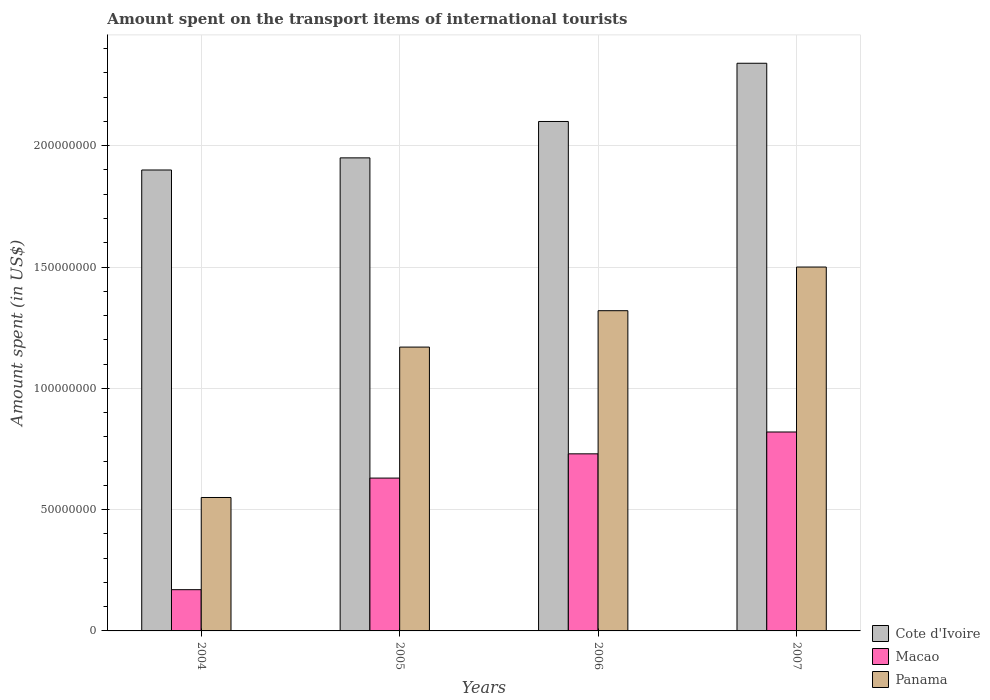How many different coloured bars are there?
Provide a succinct answer. 3. How many groups of bars are there?
Give a very brief answer. 4. Are the number of bars per tick equal to the number of legend labels?
Provide a short and direct response. Yes. What is the label of the 1st group of bars from the left?
Provide a succinct answer. 2004. What is the amount spent on the transport items of international tourists in Panama in 2007?
Offer a very short reply. 1.50e+08. Across all years, what is the maximum amount spent on the transport items of international tourists in Macao?
Provide a short and direct response. 8.20e+07. Across all years, what is the minimum amount spent on the transport items of international tourists in Cote d'Ivoire?
Offer a very short reply. 1.90e+08. In which year was the amount spent on the transport items of international tourists in Macao minimum?
Offer a terse response. 2004. What is the total amount spent on the transport items of international tourists in Macao in the graph?
Give a very brief answer. 2.35e+08. What is the difference between the amount spent on the transport items of international tourists in Panama in 2004 and that in 2007?
Keep it short and to the point. -9.50e+07. What is the difference between the amount spent on the transport items of international tourists in Panama in 2007 and the amount spent on the transport items of international tourists in Macao in 2004?
Give a very brief answer. 1.33e+08. What is the average amount spent on the transport items of international tourists in Macao per year?
Ensure brevity in your answer.  5.88e+07. In the year 2004, what is the difference between the amount spent on the transport items of international tourists in Panama and amount spent on the transport items of international tourists in Macao?
Give a very brief answer. 3.80e+07. What is the ratio of the amount spent on the transport items of international tourists in Panama in 2006 to that in 2007?
Your answer should be compact. 0.88. What is the difference between the highest and the second highest amount spent on the transport items of international tourists in Macao?
Provide a short and direct response. 9.00e+06. What is the difference between the highest and the lowest amount spent on the transport items of international tourists in Panama?
Make the answer very short. 9.50e+07. In how many years, is the amount spent on the transport items of international tourists in Cote d'Ivoire greater than the average amount spent on the transport items of international tourists in Cote d'Ivoire taken over all years?
Provide a short and direct response. 2. Is the sum of the amount spent on the transport items of international tourists in Macao in 2005 and 2007 greater than the maximum amount spent on the transport items of international tourists in Panama across all years?
Keep it short and to the point. No. What does the 1st bar from the left in 2004 represents?
Give a very brief answer. Cote d'Ivoire. What does the 3rd bar from the right in 2005 represents?
Ensure brevity in your answer.  Cote d'Ivoire. Is it the case that in every year, the sum of the amount spent on the transport items of international tourists in Panama and amount spent on the transport items of international tourists in Macao is greater than the amount spent on the transport items of international tourists in Cote d'Ivoire?
Your response must be concise. No. Are all the bars in the graph horizontal?
Your answer should be very brief. No. How many years are there in the graph?
Keep it short and to the point. 4. What is the difference between two consecutive major ticks on the Y-axis?
Offer a terse response. 5.00e+07. Are the values on the major ticks of Y-axis written in scientific E-notation?
Provide a short and direct response. No. Does the graph contain grids?
Your answer should be compact. Yes. How many legend labels are there?
Give a very brief answer. 3. How are the legend labels stacked?
Your response must be concise. Vertical. What is the title of the graph?
Your answer should be compact. Amount spent on the transport items of international tourists. Does "Palau" appear as one of the legend labels in the graph?
Make the answer very short. No. What is the label or title of the X-axis?
Make the answer very short. Years. What is the label or title of the Y-axis?
Your response must be concise. Amount spent (in US$). What is the Amount spent (in US$) in Cote d'Ivoire in 2004?
Your answer should be very brief. 1.90e+08. What is the Amount spent (in US$) of Macao in 2004?
Ensure brevity in your answer.  1.70e+07. What is the Amount spent (in US$) of Panama in 2004?
Your answer should be very brief. 5.50e+07. What is the Amount spent (in US$) of Cote d'Ivoire in 2005?
Offer a very short reply. 1.95e+08. What is the Amount spent (in US$) of Macao in 2005?
Your answer should be compact. 6.30e+07. What is the Amount spent (in US$) in Panama in 2005?
Provide a succinct answer. 1.17e+08. What is the Amount spent (in US$) of Cote d'Ivoire in 2006?
Ensure brevity in your answer.  2.10e+08. What is the Amount spent (in US$) of Macao in 2006?
Ensure brevity in your answer.  7.30e+07. What is the Amount spent (in US$) in Panama in 2006?
Your answer should be very brief. 1.32e+08. What is the Amount spent (in US$) of Cote d'Ivoire in 2007?
Provide a succinct answer. 2.34e+08. What is the Amount spent (in US$) in Macao in 2007?
Provide a short and direct response. 8.20e+07. What is the Amount spent (in US$) of Panama in 2007?
Offer a very short reply. 1.50e+08. Across all years, what is the maximum Amount spent (in US$) in Cote d'Ivoire?
Your answer should be very brief. 2.34e+08. Across all years, what is the maximum Amount spent (in US$) in Macao?
Offer a very short reply. 8.20e+07. Across all years, what is the maximum Amount spent (in US$) of Panama?
Your answer should be compact. 1.50e+08. Across all years, what is the minimum Amount spent (in US$) in Cote d'Ivoire?
Make the answer very short. 1.90e+08. Across all years, what is the minimum Amount spent (in US$) in Macao?
Your answer should be very brief. 1.70e+07. Across all years, what is the minimum Amount spent (in US$) of Panama?
Offer a terse response. 5.50e+07. What is the total Amount spent (in US$) of Cote d'Ivoire in the graph?
Your answer should be very brief. 8.29e+08. What is the total Amount spent (in US$) of Macao in the graph?
Your answer should be compact. 2.35e+08. What is the total Amount spent (in US$) in Panama in the graph?
Your response must be concise. 4.54e+08. What is the difference between the Amount spent (in US$) of Cote d'Ivoire in 2004 and that in 2005?
Provide a short and direct response. -5.00e+06. What is the difference between the Amount spent (in US$) in Macao in 2004 and that in 2005?
Offer a terse response. -4.60e+07. What is the difference between the Amount spent (in US$) of Panama in 2004 and that in 2005?
Offer a very short reply. -6.20e+07. What is the difference between the Amount spent (in US$) in Cote d'Ivoire in 2004 and that in 2006?
Your response must be concise. -2.00e+07. What is the difference between the Amount spent (in US$) of Macao in 2004 and that in 2006?
Make the answer very short. -5.60e+07. What is the difference between the Amount spent (in US$) in Panama in 2004 and that in 2006?
Give a very brief answer. -7.70e+07. What is the difference between the Amount spent (in US$) in Cote d'Ivoire in 2004 and that in 2007?
Provide a succinct answer. -4.40e+07. What is the difference between the Amount spent (in US$) in Macao in 2004 and that in 2007?
Offer a terse response. -6.50e+07. What is the difference between the Amount spent (in US$) in Panama in 2004 and that in 2007?
Provide a succinct answer. -9.50e+07. What is the difference between the Amount spent (in US$) of Cote d'Ivoire in 2005 and that in 2006?
Offer a very short reply. -1.50e+07. What is the difference between the Amount spent (in US$) in Macao in 2005 and that in 2006?
Offer a terse response. -1.00e+07. What is the difference between the Amount spent (in US$) of Panama in 2005 and that in 2006?
Provide a short and direct response. -1.50e+07. What is the difference between the Amount spent (in US$) in Cote d'Ivoire in 2005 and that in 2007?
Offer a terse response. -3.90e+07. What is the difference between the Amount spent (in US$) in Macao in 2005 and that in 2007?
Give a very brief answer. -1.90e+07. What is the difference between the Amount spent (in US$) in Panama in 2005 and that in 2007?
Provide a succinct answer. -3.30e+07. What is the difference between the Amount spent (in US$) of Cote d'Ivoire in 2006 and that in 2007?
Provide a short and direct response. -2.40e+07. What is the difference between the Amount spent (in US$) of Macao in 2006 and that in 2007?
Offer a terse response. -9.00e+06. What is the difference between the Amount spent (in US$) of Panama in 2006 and that in 2007?
Provide a succinct answer. -1.80e+07. What is the difference between the Amount spent (in US$) in Cote d'Ivoire in 2004 and the Amount spent (in US$) in Macao in 2005?
Your answer should be very brief. 1.27e+08. What is the difference between the Amount spent (in US$) in Cote d'Ivoire in 2004 and the Amount spent (in US$) in Panama in 2005?
Provide a short and direct response. 7.30e+07. What is the difference between the Amount spent (in US$) in Macao in 2004 and the Amount spent (in US$) in Panama in 2005?
Your response must be concise. -1.00e+08. What is the difference between the Amount spent (in US$) in Cote d'Ivoire in 2004 and the Amount spent (in US$) in Macao in 2006?
Your answer should be very brief. 1.17e+08. What is the difference between the Amount spent (in US$) of Cote d'Ivoire in 2004 and the Amount spent (in US$) of Panama in 2006?
Offer a terse response. 5.80e+07. What is the difference between the Amount spent (in US$) in Macao in 2004 and the Amount spent (in US$) in Panama in 2006?
Make the answer very short. -1.15e+08. What is the difference between the Amount spent (in US$) of Cote d'Ivoire in 2004 and the Amount spent (in US$) of Macao in 2007?
Make the answer very short. 1.08e+08. What is the difference between the Amount spent (in US$) in Cote d'Ivoire in 2004 and the Amount spent (in US$) in Panama in 2007?
Provide a short and direct response. 4.00e+07. What is the difference between the Amount spent (in US$) of Macao in 2004 and the Amount spent (in US$) of Panama in 2007?
Your answer should be compact. -1.33e+08. What is the difference between the Amount spent (in US$) in Cote d'Ivoire in 2005 and the Amount spent (in US$) in Macao in 2006?
Your answer should be compact. 1.22e+08. What is the difference between the Amount spent (in US$) in Cote d'Ivoire in 2005 and the Amount spent (in US$) in Panama in 2006?
Your answer should be compact. 6.30e+07. What is the difference between the Amount spent (in US$) in Macao in 2005 and the Amount spent (in US$) in Panama in 2006?
Your answer should be very brief. -6.90e+07. What is the difference between the Amount spent (in US$) in Cote d'Ivoire in 2005 and the Amount spent (in US$) in Macao in 2007?
Ensure brevity in your answer.  1.13e+08. What is the difference between the Amount spent (in US$) in Cote d'Ivoire in 2005 and the Amount spent (in US$) in Panama in 2007?
Make the answer very short. 4.50e+07. What is the difference between the Amount spent (in US$) of Macao in 2005 and the Amount spent (in US$) of Panama in 2007?
Your response must be concise. -8.70e+07. What is the difference between the Amount spent (in US$) in Cote d'Ivoire in 2006 and the Amount spent (in US$) in Macao in 2007?
Give a very brief answer. 1.28e+08. What is the difference between the Amount spent (in US$) of Cote d'Ivoire in 2006 and the Amount spent (in US$) of Panama in 2007?
Offer a very short reply. 6.00e+07. What is the difference between the Amount spent (in US$) of Macao in 2006 and the Amount spent (in US$) of Panama in 2007?
Your response must be concise. -7.70e+07. What is the average Amount spent (in US$) in Cote d'Ivoire per year?
Provide a succinct answer. 2.07e+08. What is the average Amount spent (in US$) of Macao per year?
Ensure brevity in your answer.  5.88e+07. What is the average Amount spent (in US$) in Panama per year?
Your answer should be compact. 1.14e+08. In the year 2004, what is the difference between the Amount spent (in US$) of Cote d'Ivoire and Amount spent (in US$) of Macao?
Offer a terse response. 1.73e+08. In the year 2004, what is the difference between the Amount spent (in US$) of Cote d'Ivoire and Amount spent (in US$) of Panama?
Provide a succinct answer. 1.35e+08. In the year 2004, what is the difference between the Amount spent (in US$) in Macao and Amount spent (in US$) in Panama?
Give a very brief answer. -3.80e+07. In the year 2005, what is the difference between the Amount spent (in US$) of Cote d'Ivoire and Amount spent (in US$) of Macao?
Give a very brief answer. 1.32e+08. In the year 2005, what is the difference between the Amount spent (in US$) of Cote d'Ivoire and Amount spent (in US$) of Panama?
Keep it short and to the point. 7.80e+07. In the year 2005, what is the difference between the Amount spent (in US$) in Macao and Amount spent (in US$) in Panama?
Offer a very short reply. -5.40e+07. In the year 2006, what is the difference between the Amount spent (in US$) in Cote d'Ivoire and Amount spent (in US$) in Macao?
Offer a very short reply. 1.37e+08. In the year 2006, what is the difference between the Amount spent (in US$) in Cote d'Ivoire and Amount spent (in US$) in Panama?
Ensure brevity in your answer.  7.80e+07. In the year 2006, what is the difference between the Amount spent (in US$) in Macao and Amount spent (in US$) in Panama?
Ensure brevity in your answer.  -5.90e+07. In the year 2007, what is the difference between the Amount spent (in US$) in Cote d'Ivoire and Amount spent (in US$) in Macao?
Provide a succinct answer. 1.52e+08. In the year 2007, what is the difference between the Amount spent (in US$) of Cote d'Ivoire and Amount spent (in US$) of Panama?
Ensure brevity in your answer.  8.40e+07. In the year 2007, what is the difference between the Amount spent (in US$) of Macao and Amount spent (in US$) of Panama?
Provide a short and direct response. -6.80e+07. What is the ratio of the Amount spent (in US$) in Cote d'Ivoire in 2004 to that in 2005?
Give a very brief answer. 0.97. What is the ratio of the Amount spent (in US$) of Macao in 2004 to that in 2005?
Make the answer very short. 0.27. What is the ratio of the Amount spent (in US$) of Panama in 2004 to that in 2005?
Provide a succinct answer. 0.47. What is the ratio of the Amount spent (in US$) in Cote d'Ivoire in 2004 to that in 2006?
Your response must be concise. 0.9. What is the ratio of the Amount spent (in US$) of Macao in 2004 to that in 2006?
Provide a succinct answer. 0.23. What is the ratio of the Amount spent (in US$) in Panama in 2004 to that in 2006?
Your response must be concise. 0.42. What is the ratio of the Amount spent (in US$) in Cote d'Ivoire in 2004 to that in 2007?
Make the answer very short. 0.81. What is the ratio of the Amount spent (in US$) in Macao in 2004 to that in 2007?
Your answer should be very brief. 0.21. What is the ratio of the Amount spent (in US$) of Panama in 2004 to that in 2007?
Offer a terse response. 0.37. What is the ratio of the Amount spent (in US$) in Macao in 2005 to that in 2006?
Your answer should be compact. 0.86. What is the ratio of the Amount spent (in US$) of Panama in 2005 to that in 2006?
Offer a terse response. 0.89. What is the ratio of the Amount spent (in US$) in Cote d'Ivoire in 2005 to that in 2007?
Offer a very short reply. 0.83. What is the ratio of the Amount spent (in US$) in Macao in 2005 to that in 2007?
Give a very brief answer. 0.77. What is the ratio of the Amount spent (in US$) in Panama in 2005 to that in 2007?
Offer a very short reply. 0.78. What is the ratio of the Amount spent (in US$) of Cote d'Ivoire in 2006 to that in 2007?
Offer a terse response. 0.9. What is the ratio of the Amount spent (in US$) in Macao in 2006 to that in 2007?
Offer a very short reply. 0.89. What is the difference between the highest and the second highest Amount spent (in US$) of Cote d'Ivoire?
Your answer should be very brief. 2.40e+07. What is the difference between the highest and the second highest Amount spent (in US$) in Macao?
Your answer should be compact. 9.00e+06. What is the difference between the highest and the second highest Amount spent (in US$) of Panama?
Your answer should be very brief. 1.80e+07. What is the difference between the highest and the lowest Amount spent (in US$) of Cote d'Ivoire?
Make the answer very short. 4.40e+07. What is the difference between the highest and the lowest Amount spent (in US$) of Macao?
Keep it short and to the point. 6.50e+07. What is the difference between the highest and the lowest Amount spent (in US$) in Panama?
Your answer should be very brief. 9.50e+07. 